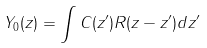Convert formula to latex. <formula><loc_0><loc_0><loc_500><loc_500>Y _ { 0 } ( z ) = \int C ( z ^ { \prime } ) R ( z - z ^ { \prime } ) d z ^ { \prime }</formula> 